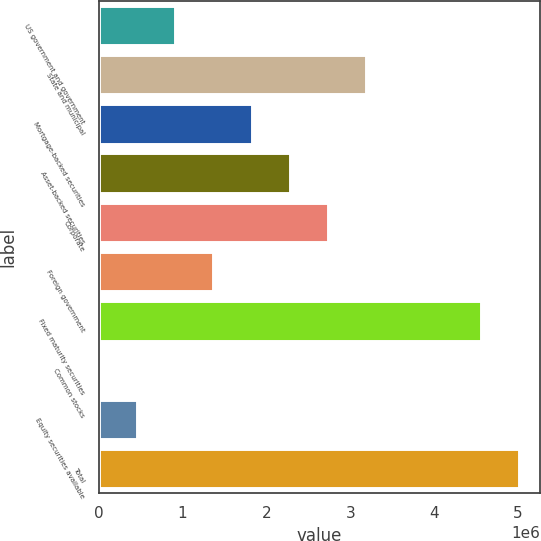<chart> <loc_0><loc_0><loc_500><loc_500><bar_chart><fcel>US government and government<fcel>State and municipal<fcel>Mortgage-backed securities<fcel>Asset-backed securities<fcel>Corporate<fcel>Foreign government<fcel>Fixed maturity securities<fcel>Common stocks<fcel>Equity securities available<fcel>Total<nl><fcel>912447<fcel>3.19272e+06<fcel>1.82456e+06<fcel>2.28061e+06<fcel>2.73667e+06<fcel>1.3685e+06<fcel>4.56055e+06<fcel>336<fcel>456391<fcel>5.01661e+06<nl></chart> 